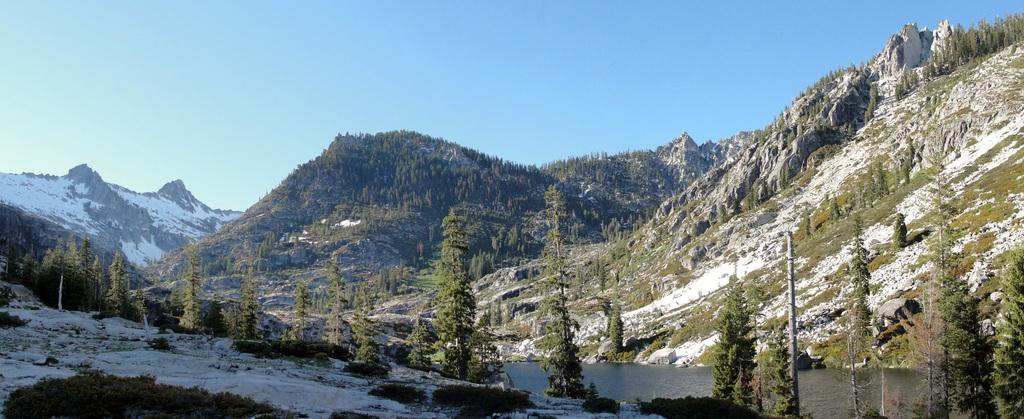What type of natural environment is depicted in the image? The image features many trees and hills, suggesting a forested or hilly landscape. What can be seen in the background of the image? The sky is visible in the background of the image. What memory does the curve in the image evoke for the viewer? There is no curve present in the image, so it cannot evoke any memory. 